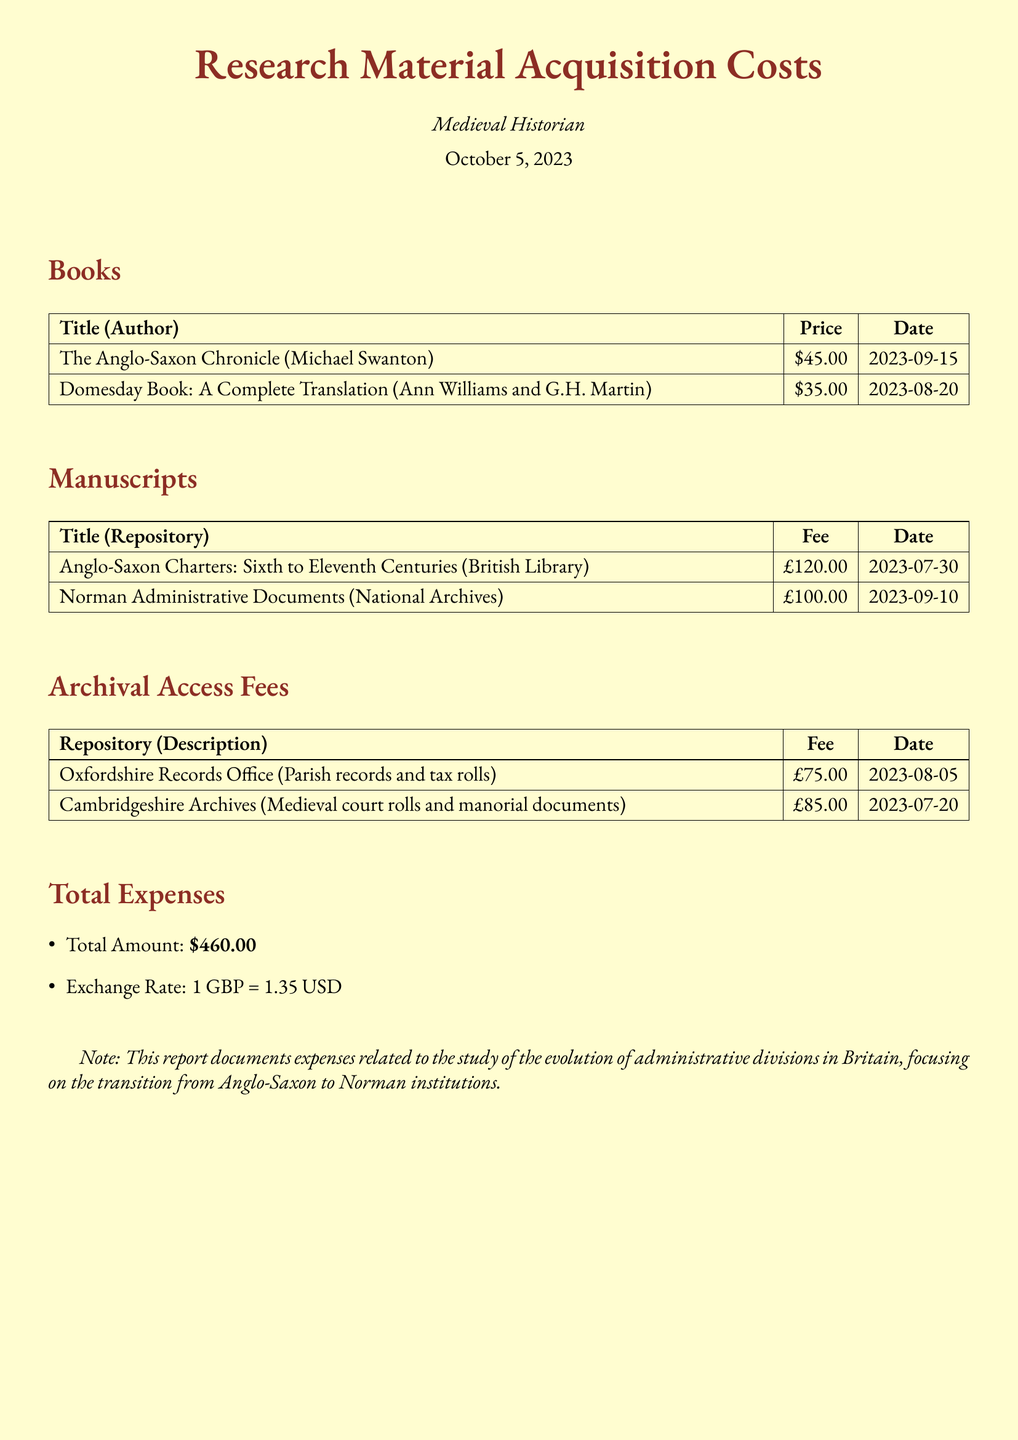What is the total amount? The total expenses are clearly stated in the document as "Total Amount: $460.00."
Answer: $460.00 What is the price of "The Anglo-Saxon Chronicle"? The price listed for "The Anglo-Saxon Chronicle" is specified under the Books section as "$45.00."
Answer: $45.00 Which manuscript costs £100.00? The document states "Norman Administrative Documents" as the manuscript with this cost in the Manuscripts section.
Answer: Norman Administrative Documents What date was "Domesday Book: A Complete Translation" purchased? The date for the purchase of "Domesday Book: A Complete Translation" is indicated as "2023-08-20" in the Books section.
Answer: 2023-08-20 How much was spent on archival access fees? To calculate this, we sum the fees for the archival access listed, which are £75.00 and £85.00. The total is £160.00, which is mentioned in the document.
Answer: £160.00 From which repository are "Anglo-Saxon Charters" available? The document specifies "British Library" as the repository for "Anglo-Saxon Charters: Sixth to Eleventh Centuries."
Answer: British Library What is the fee for accessing Cambridgeshire Archives? The fee listed for Cambridgeshire Archives is provided as "£85.00" in the Archival Access Fees section.
Answer: £85.00 What is the exchange rate mentioned in the report? The report states the exchange rate as "1 GBP = 1.35 USD."
Answer: 1 GBP = 1.35 USD Which book was acquired on 2023-09-15? The book acquired on this date is "The Anglo-Saxon Chronicle" as specified in the Books section.
Answer: The Anglo-Saxon Chronicle 